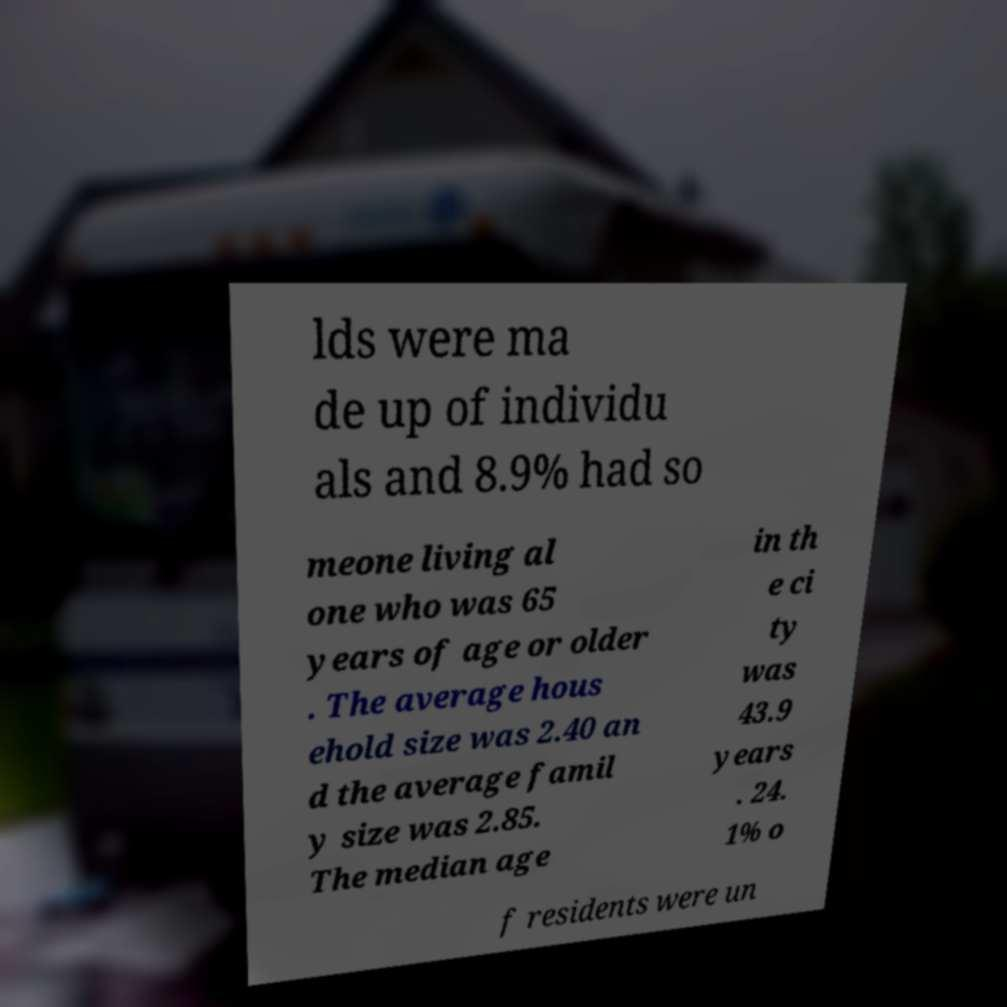Please identify and transcribe the text found in this image. lds were ma de up of individu als and 8.9% had so meone living al one who was 65 years of age or older . The average hous ehold size was 2.40 an d the average famil y size was 2.85. The median age in th e ci ty was 43.9 years . 24. 1% o f residents were un 